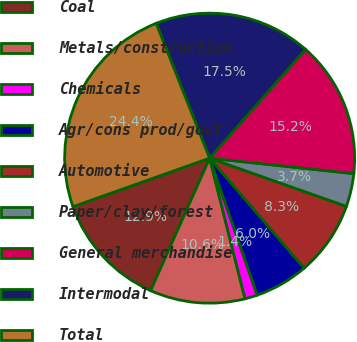Convert chart to OTSL. <chart><loc_0><loc_0><loc_500><loc_500><pie_chart><fcel>Coal<fcel>Metals/construction<fcel>Chemicals<fcel>Agr/cons prod/govt<fcel>Automotive<fcel>Paper/clay/forest<fcel>General merchandise<fcel>Intermodal<fcel>Total<nl><fcel>12.9%<fcel>10.6%<fcel>1.39%<fcel>5.99%<fcel>8.3%<fcel>3.69%<fcel>15.21%<fcel>17.51%<fcel>24.42%<nl></chart> 